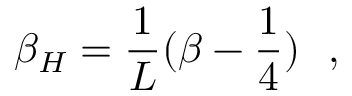<formula> <loc_0><loc_0><loc_500><loc_500>\beta _ { H } = { \frac { 1 } { L } } ( \beta - { \frac { 1 } { 4 } } ) ,</formula> 